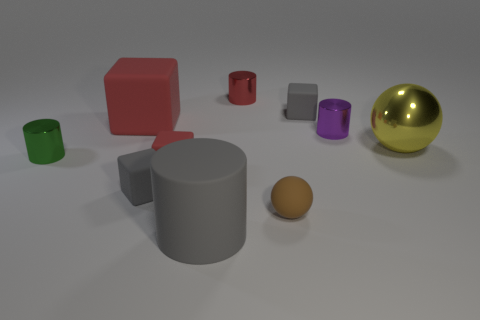Subtract 1 cylinders. How many cylinders are left? 3 Subtract all green spheres. Subtract all gray cylinders. How many spheres are left? 2 Subtract all cylinders. How many objects are left? 6 Subtract all small green things. Subtract all purple cylinders. How many objects are left? 8 Add 2 small metallic objects. How many small metallic objects are left? 5 Add 10 cyan blocks. How many cyan blocks exist? 10 Subtract 0 cyan spheres. How many objects are left? 10 